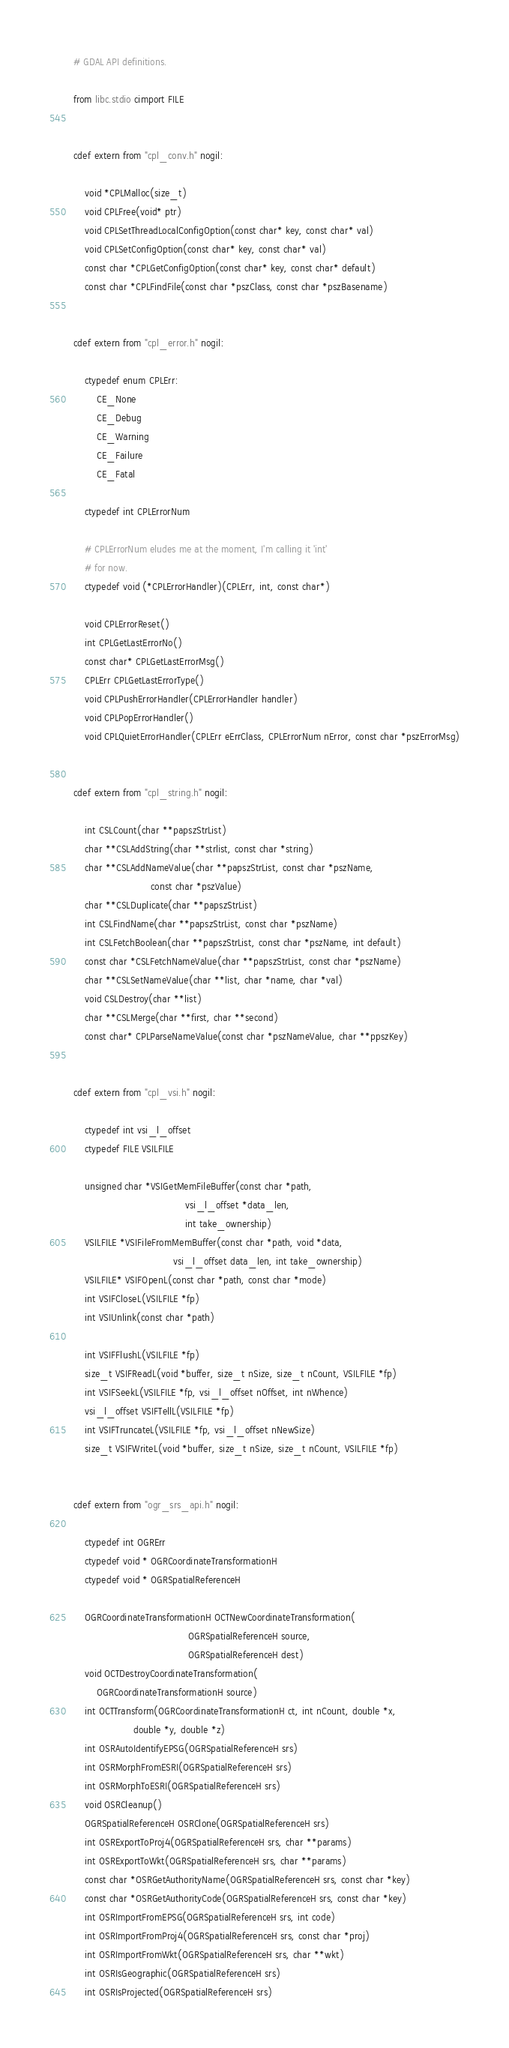<code> <loc_0><loc_0><loc_500><loc_500><_Cython_># GDAL API definitions.

from libc.stdio cimport FILE


cdef extern from "cpl_conv.h" nogil:

    void *CPLMalloc(size_t)
    void CPLFree(void* ptr)
    void CPLSetThreadLocalConfigOption(const char* key, const char* val)
    void CPLSetConfigOption(const char* key, const char* val)
    const char *CPLGetConfigOption(const char* key, const char* default)
    const char *CPLFindFile(const char *pszClass, const char *pszBasename)


cdef extern from "cpl_error.h" nogil:

    ctypedef enum CPLErr:
        CE_None
        CE_Debug
        CE_Warning
        CE_Failure
        CE_Fatal

    ctypedef int CPLErrorNum

    # CPLErrorNum eludes me at the moment, I'm calling it 'int'
    # for now.
    ctypedef void (*CPLErrorHandler)(CPLErr, int, const char*)

    void CPLErrorReset()
    int CPLGetLastErrorNo()
    const char* CPLGetLastErrorMsg()
    CPLErr CPLGetLastErrorType()
    void CPLPushErrorHandler(CPLErrorHandler handler)
    void CPLPopErrorHandler()
    void CPLQuietErrorHandler(CPLErr eErrClass, CPLErrorNum nError, const char *pszErrorMsg)


cdef extern from "cpl_string.h" nogil:

    int CSLCount(char **papszStrList)
    char **CSLAddString(char **strlist, const char *string)
    char **CSLAddNameValue(char **papszStrList, const char *pszName,
                           const char *pszValue)
    char **CSLDuplicate(char **papszStrList)
    int CSLFindName(char **papszStrList, const char *pszName)
    int CSLFetchBoolean(char **papszStrList, const char *pszName, int default)
    const char *CSLFetchNameValue(char **papszStrList, const char *pszName)
    char **CSLSetNameValue(char **list, char *name, char *val)
    void CSLDestroy(char **list)
    char **CSLMerge(char **first, char **second)
    const char* CPLParseNameValue(const char *pszNameValue, char **ppszKey)


cdef extern from "cpl_vsi.h" nogil:

    ctypedef int vsi_l_offset
    ctypedef FILE VSILFILE

    unsigned char *VSIGetMemFileBuffer(const char *path,
                                       vsi_l_offset *data_len,
                                       int take_ownership)
    VSILFILE *VSIFileFromMemBuffer(const char *path, void *data,
                                   vsi_l_offset data_len, int take_ownership)
    VSILFILE* VSIFOpenL(const char *path, const char *mode)
    int VSIFCloseL(VSILFILE *fp)
    int VSIUnlink(const char *path)

    int VSIFFlushL(VSILFILE *fp)
    size_t VSIFReadL(void *buffer, size_t nSize, size_t nCount, VSILFILE *fp)
    int VSIFSeekL(VSILFILE *fp, vsi_l_offset nOffset, int nWhence)
    vsi_l_offset VSIFTellL(VSILFILE *fp)
    int VSIFTruncateL(VSILFILE *fp, vsi_l_offset nNewSize)
    size_t VSIFWriteL(void *buffer, size_t nSize, size_t nCount, VSILFILE *fp)


cdef extern from "ogr_srs_api.h" nogil:

    ctypedef int OGRErr
    ctypedef void * OGRCoordinateTransformationH
    ctypedef void * OGRSpatialReferenceH

    OGRCoordinateTransformationH OCTNewCoordinateTransformation(
                                        OGRSpatialReferenceH source,
                                        OGRSpatialReferenceH dest)
    void OCTDestroyCoordinateTransformation(
        OGRCoordinateTransformationH source)
    int OCTTransform(OGRCoordinateTransformationH ct, int nCount, double *x,
                     double *y, double *z)
    int OSRAutoIdentifyEPSG(OGRSpatialReferenceH srs)
    int OSRMorphFromESRI(OGRSpatialReferenceH srs)
    int OSRMorphToESRI(OGRSpatialReferenceH srs)
    void OSRCleanup()
    OGRSpatialReferenceH OSRClone(OGRSpatialReferenceH srs)
    int OSRExportToProj4(OGRSpatialReferenceH srs, char **params)
    int OSRExportToWkt(OGRSpatialReferenceH srs, char **params)
    const char *OSRGetAuthorityName(OGRSpatialReferenceH srs, const char *key)
    const char *OSRGetAuthorityCode(OGRSpatialReferenceH srs, const char *key)
    int OSRImportFromEPSG(OGRSpatialReferenceH srs, int code)
    int OSRImportFromProj4(OGRSpatialReferenceH srs, const char *proj)
    int OSRImportFromWkt(OGRSpatialReferenceH srs, char **wkt)
    int OSRIsGeographic(OGRSpatialReferenceH srs)
    int OSRIsProjected(OGRSpatialReferenceH srs)</code> 